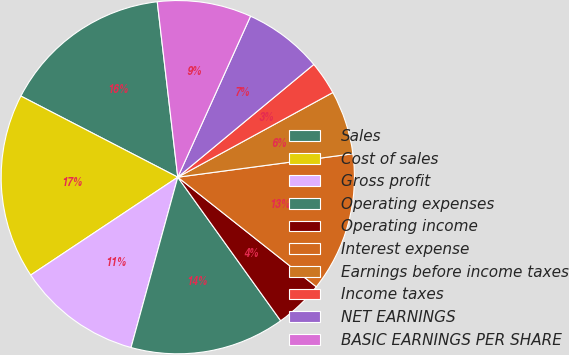<chart> <loc_0><loc_0><loc_500><loc_500><pie_chart><fcel>Sales<fcel>Cost of sales<fcel>Gross profit<fcel>Operating expenses<fcel>Operating income<fcel>Interest expense<fcel>Earnings before income taxes<fcel>Income taxes<fcel>NET EARNINGS<fcel>BASIC EARNINGS PER SHARE<nl><fcel>15.55%<fcel>16.94%<fcel>11.39%<fcel>14.16%<fcel>4.45%<fcel>12.77%<fcel>5.84%<fcel>3.06%<fcel>7.23%<fcel>8.61%<nl></chart> 